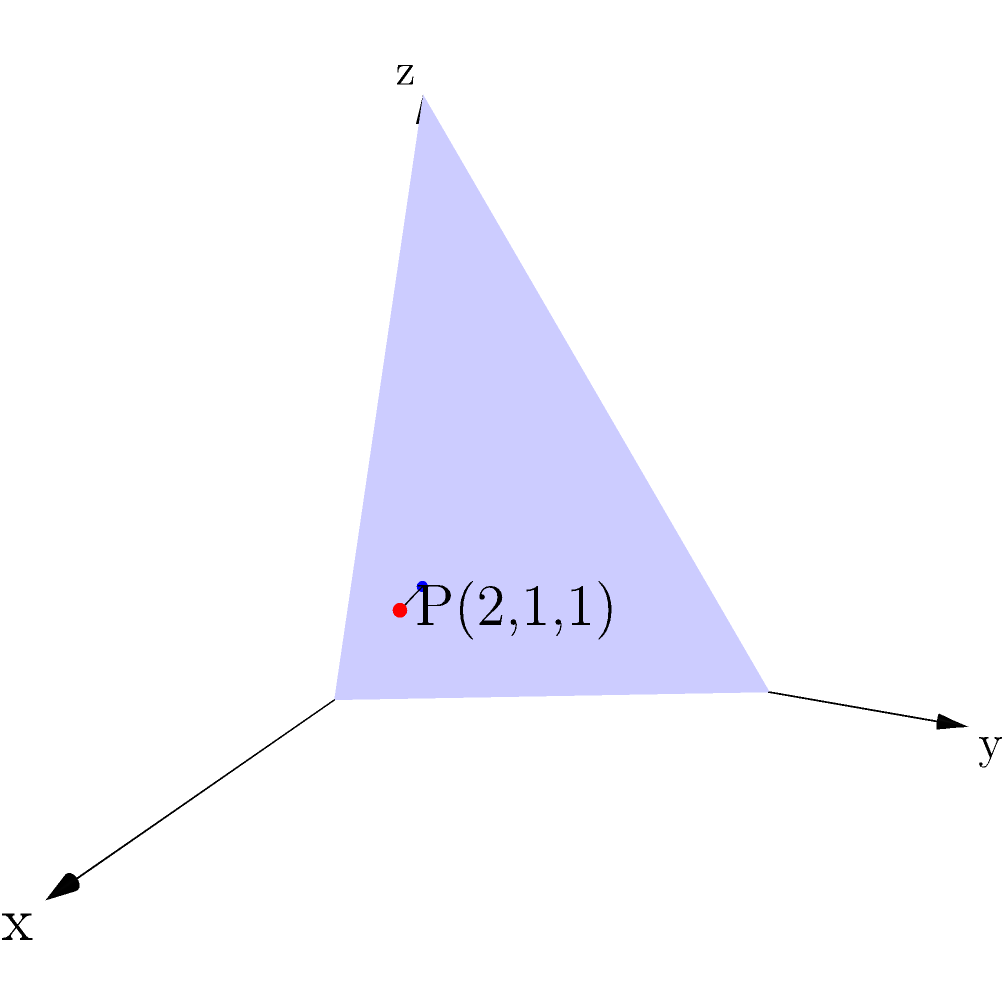As a team lead working with a software engineer and a senior Portuguese researcher, you're presented with a 3D visualization problem. Given a plane passing through points $A(1,0,0)$, $B(0,2,0)$, and $C(0,0,3)$, and a point $P(2,1,1)$, calculate the shortest distance from point $P$ to the plane. How would you approach this problem collaboratively, and what is the final result? Let's approach this problem step-by-step:

1) First, we need to find the normal vector of the plane. We can do this by calculating the cross product of two vectors on the plane:
   $\vec{AB} = (-1,2,0)$ and $\vec{AC} = (-1,0,3)$
   $\vec{n} = \vec{AB} \times \vec{AC} = (6,3,-2)$

2) The general equation of a plane is $ax + by + cz + d = 0$, where $(a,b,c)$ is the normal vector. So our plane equation is:
   $6x + 3y - 2z + d = 0$

3) To find $d$, we can substitute the coordinates of point $A$:
   $6(1) + 3(0) - 2(0) + d = 0$
   $d = -6$

4) So the plane equation is: $6x + 3y - 2z - 6 = 0$

5) The formula for the distance from a point $(x_0, y_0, z_0)$ to a plane $ax + by + cz + d = 0$ is:
   $D = \frac{|ax_0 + by_0 + cz_0 + d|}{\sqrt{a^2 + b^2 + c^2}}$

6) Substituting our values:
   $D = \frac{|6(2) + 3(1) - 2(1) - 6|}{\sqrt{6^2 + 3^2 + (-2)^2}}$
   $= \frac{|12 + 3 - 2 - 6|}{\sqrt{36 + 9 + 4}}$
   $= \frac{7}{\sqrt{49}}$
   $= \frac{7}{7} = 1$

Therefore, the shortest distance from point $P$ to the plane is 1 unit.
Answer: 1 unit 